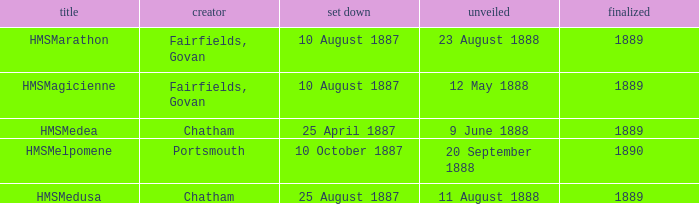Which builder completed before 1890 and launched on 9 june 1888? Chatham. 